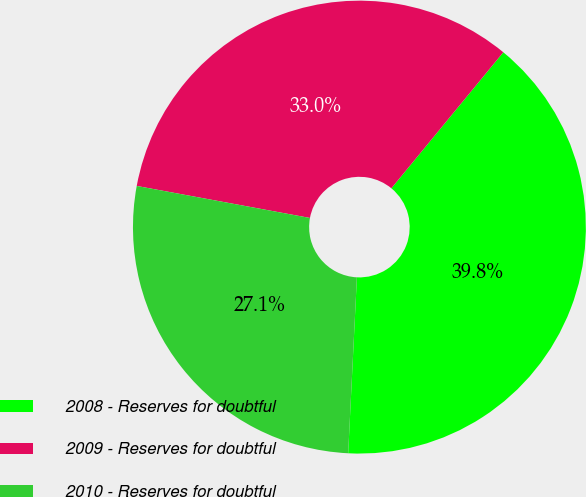Convert chart. <chart><loc_0><loc_0><loc_500><loc_500><pie_chart><fcel>2008 - Reserves for doubtful<fcel>2009 - Reserves for doubtful<fcel>2010 - Reserves for doubtful<nl><fcel>39.83%<fcel>33.05%<fcel>27.12%<nl></chart> 